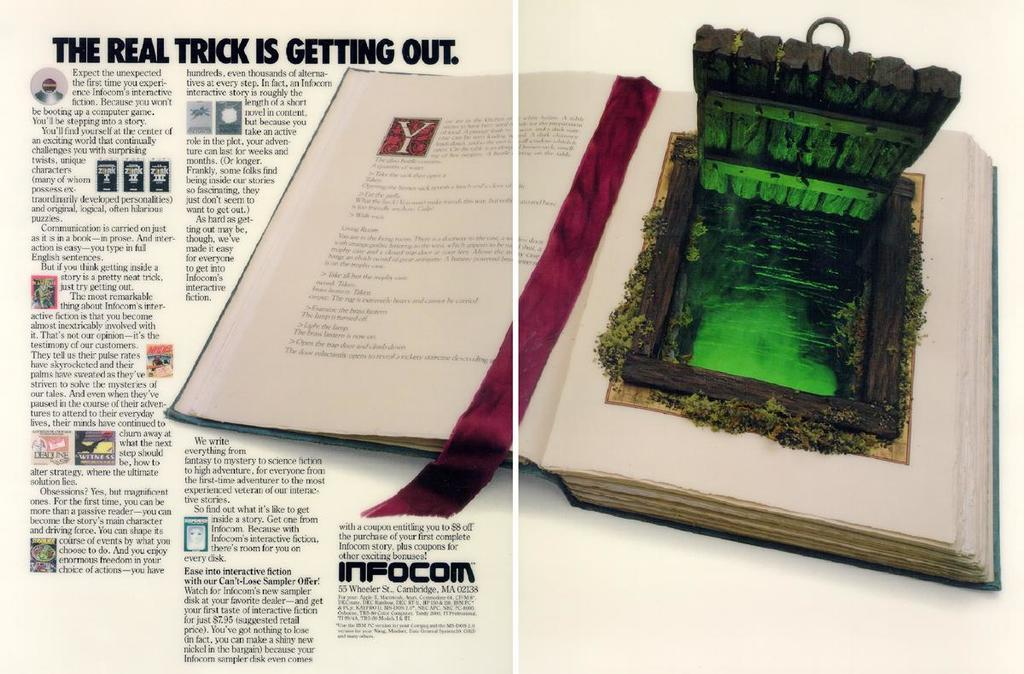Provide a one-sentence caption for the provided image. An interactive book is displayed in an advertisement for infocom where The Real Trick is Getting Out. 